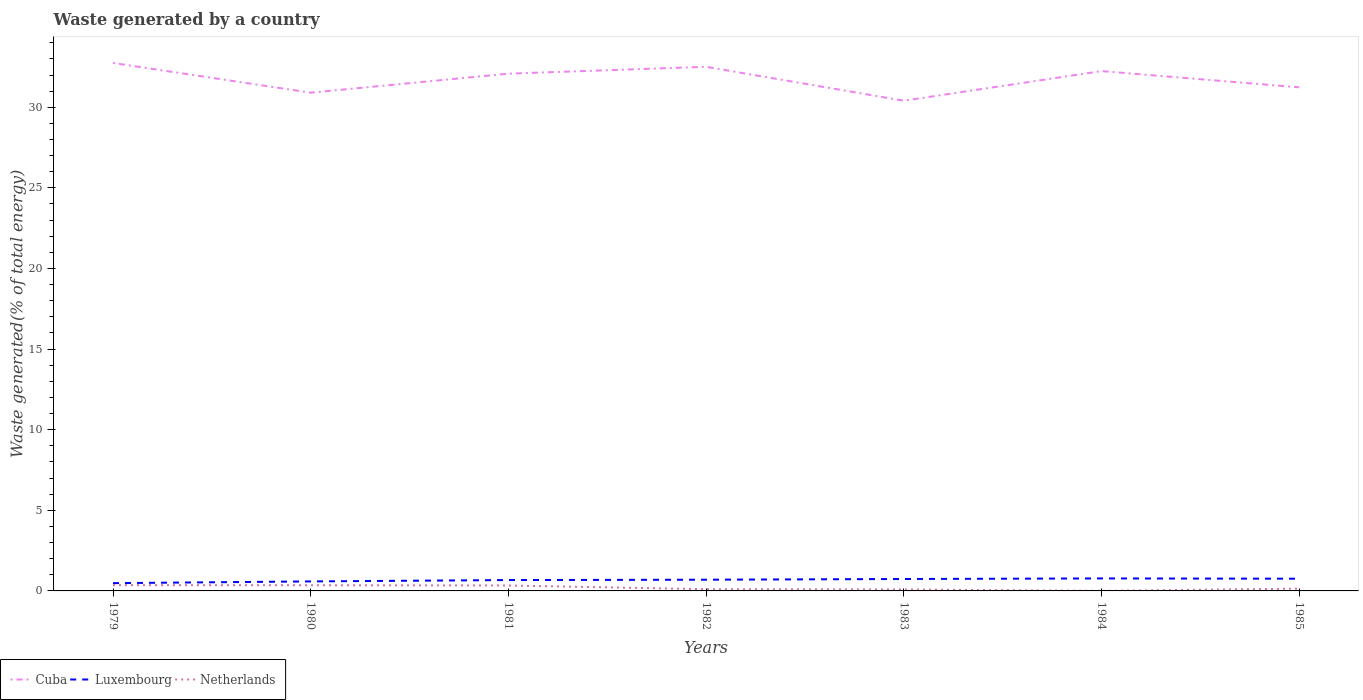How many different coloured lines are there?
Offer a terse response. 3. Is the number of lines equal to the number of legend labels?
Provide a short and direct response. Yes. Across all years, what is the maximum total waste generated in Netherlands?
Offer a terse response. 0.01. What is the total total waste generated in Cuba in the graph?
Provide a short and direct response. -1.61. What is the difference between the highest and the second highest total waste generated in Cuba?
Give a very brief answer. 2.34. Is the total waste generated in Luxembourg strictly greater than the total waste generated in Cuba over the years?
Offer a very short reply. Yes. How many lines are there?
Give a very brief answer. 3. What is the difference between two consecutive major ticks on the Y-axis?
Your answer should be very brief. 5. Where does the legend appear in the graph?
Make the answer very short. Bottom left. How are the legend labels stacked?
Offer a very short reply. Horizontal. What is the title of the graph?
Provide a succinct answer. Waste generated by a country. Does "Middle income" appear as one of the legend labels in the graph?
Give a very brief answer. No. What is the label or title of the Y-axis?
Ensure brevity in your answer.  Waste generated(% of total energy). What is the Waste generated(% of total energy) in Cuba in 1979?
Your response must be concise. 32.75. What is the Waste generated(% of total energy) of Luxembourg in 1979?
Your answer should be very brief. 0.48. What is the Waste generated(% of total energy) of Netherlands in 1979?
Offer a terse response. 0.36. What is the Waste generated(% of total energy) in Cuba in 1980?
Your response must be concise. 30.9. What is the Waste generated(% of total energy) in Luxembourg in 1980?
Offer a terse response. 0.59. What is the Waste generated(% of total energy) in Netherlands in 1980?
Keep it short and to the point. 0.35. What is the Waste generated(% of total energy) in Cuba in 1981?
Keep it short and to the point. 32.08. What is the Waste generated(% of total energy) of Luxembourg in 1981?
Provide a short and direct response. 0.67. What is the Waste generated(% of total energy) in Netherlands in 1981?
Offer a very short reply. 0.33. What is the Waste generated(% of total energy) of Cuba in 1982?
Offer a very short reply. 32.51. What is the Waste generated(% of total energy) in Luxembourg in 1982?
Ensure brevity in your answer.  0.7. What is the Waste generated(% of total energy) in Netherlands in 1982?
Give a very brief answer. 0.11. What is the Waste generated(% of total energy) in Cuba in 1983?
Provide a short and direct response. 30.41. What is the Waste generated(% of total energy) of Luxembourg in 1983?
Make the answer very short. 0.74. What is the Waste generated(% of total energy) of Netherlands in 1983?
Provide a succinct answer. 0.09. What is the Waste generated(% of total energy) of Cuba in 1984?
Make the answer very short. 32.24. What is the Waste generated(% of total energy) in Luxembourg in 1984?
Ensure brevity in your answer.  0.77. What is the Waste generated(% of total energy) in Netherlands in 1984?
Give a very brief answer. 0.01. What is the Waste generated(% of total energy) of Cuba in 1985?
Make the answer very short. 31.24. What is the Waste generated(% of total energy) of Luxembourg in 1985?
Provide a short and direct response. 0.76. What is the Waste generated(% of total energy) in Netherlands in 1985?
Provide a succinct answer. 0.14. Across all years, what is the maximum Waste generated(% of total energy) in Cuba?
Offer a very short reply. 32.75. Across all years, what is the maximum Waste generated(% of total energy) in Luxembourg?
Provide a succinct answer. 0.77. Across all years, what is the maximum Waste generated(% of total energy) of Netherlands?
Offer a terse response. 0.36. Across all years, what is the minimum Waste generated(% of total energy) in Cuba?
Offer a very short reply. 30.41. Across all years, what is the minimum Waste generated(% of total energy) in Luxembourg?
Your answer should be very brief. 0.48. Across all years, what is the minimum Waste generated(% of total energy) in Netherlands?
Your answer should be compact. 0.01. What is the total Waste generated(% of total energy) in Cuba in the graph?
Give a very brief answer. 222.13. What is the total Waste generated(% of total energy) of Luxembourg in the graph?
Make the answer very short. 4.71. What is the total Waste generated(% of total energy) of Netherlands in the graph?
Provide a succinct answer. 1.39. What is the difference between the Waste generated(% of total energy) of Cuba in 1979 and that in 1980?
Your response must be concise. 1.84. What is the difference between the Waste generated(% of total energy) of Luxembourg in 1979 and that in 1980?
Your response must be concise. -0.11. What is the difference between the Waste generated(% of total energy) in Netherlands in 1979 and that in 1980?
Your response must be concise. 0.01. What is the difference between the Waste generated(% of total energy) in Cuba in 1979 and that in 1981?
Provide a succinct answer. 0.66. What is the difference between the Waste generated(% of total energy) of Luxembourg in 1979 and that in 1981?
Keep it short and to the point. -0.19. What is the difference between the Waste generated(% of total energy) of Netherlands in 1979 and that in 1981?
Offer a terse response. 0.02. What is the difference between the Waste generated(% of total energy) of Cuba in 1979 and that in 1982?
Your answer should be compact. 0.24. What is the difference between the Waste generated(% of total energy) of Luxembourg in 1979 and that in 1982?
Offer a terse response. -0.21. What is the difference between the Waste generated(% of total energy) of Netherlands in 1979 and that in 1982?
Give a very brief answer. 0.25. What is the difference between the Waste generated(% of total energy) of Cuba in 1979 and that in 1983?
Your answer should be compact. 2.34. What is the difference between the Waste generated(% of total energy) in Luxembourg in 1979 and that in 1983?
Keep it short and to the point. -0.26. What is the difference between the Waste generated(% of total energy) of Netherlands in 1979 and that in 1983?
Your answer should be very brief. 0.27. What is the difference between the Waste generated(% of total energy) of Cuba in 1979 and that in 1984?
Ensure brevity in your answer.  0.5. What is the difference between the Waste generated(% of total energy) of Luxembourg in 1979 and that in 1984?
Ensure brevity in your answer.  -0.29. What is the difference between the Waste generated(% of total energy) of Netherlands in 1979 and that in 1984?
Offer a very short reply. 0.35. What is the difference between the Waste generated(% of total energy) in Cuba in 1979 and that in 1985?
Provide a short and direct response. 1.51. What is the difference between the Waste generated(% of total energy) of Luxembourg in 1979 and that in 1985?
Provide a short and direct response. -0.28. What is the difference between the Waste generated(% of total energy) of Netherlands in 1979 and that in 1985?
Your answer should be very brief. 0.22. What is the difference between the Waste generated(% of total energy) of Cuba in 1980 and that in 1981?
Make the answer very short. -1.18. What is the difference between the Waste generated(% of total energy) of Luxembourg in 1980 and that in 1981?
Make the answer very short. -0.08. What is the difference between the Waste generated(% of total energy) in Netherlands in 1980 and that in 1981?
Provide a short and direct response. 0.02. What is the difference between the Waste generated(% of total energy) of Cuba in 1980 and that in 1982?
Make the answer very short. -1.61. What is the difference between the Waste generated(% of total energy) in Luxembourg in 1980 and that in 1982?
Make the answer very short. -0.11. What is the difference between the Waste generated(% of total energy) of Netherlands in 1980 and that in 1982?
Your response must be concise. 0.24. What is the difference between the Waste generated(% of total energy) of Cuba in 1980 and that in 1983?
Give a very brief answer. 0.5. What is the difference between the Waste generated(% of total energy) of Netherlands in 1980 and that in 1983?
Make the answer very short. 0.26. What is the difference between the Waste generated(% of total energy) of Cuba in 1980 and that in 1984?
Offer a terse response. -1.34. What is the difference between the Waste generated(% of total energy) of Luxembourg in 1980 and that in 1984?
Your response must be concise. -0.18. What is the difference between the Waste generated(% of total energy) of Netherlands in 1980 and that in 1984?
Your answer should be very brief. 0.35. What is the difference between the Waste generated(% of total energy) in Cuba in 1980 and that in 1985?
Your answer should be very brief. -0.33. What is the difference between the Waste generated(% of total energy) in Luxembourg in 1980 and that in 1985?
Offer a terse response. -0.17. What is the difference between the Waste generated(% of total energy) of Netherlands in 1980 and that in 1985?
Provide a short and direct response. 0.21. What is the difference between the Waste generated(% of total energy) in Cuba in 1981 and that in 1982?
Provide a short and direct response. -0.43. What is the difference between the Waste generated(% of total energy) of Luxembourg in 1981 and that in 1982?
Your response must be concise. -0.02. What is the difference between the Waste generated(% of total energy) of Netherlands in 1981 and that in 1982?
Offer a terse response. 0.23. What is the difference between the Waste generated(% of total energy) of Cuba in 1981 and that in 1983?
Your response must be concise. 1.68. What is the difference between the Waste generated(% of total energy) in Luxembourg in 1981 and that in 1983?
Keep it short and to the point. -0.07. What is the difference between the Waste generated(% of total energy) of Netherlands in 1981 and that in 1983?
Your response must be concise. 0.24. What is the difference between the Waste generated(% of total energy) of Cuba in 1981 and that in 1984?
Your response must be concise. -0.16. What is the difference between the Waste generated(% of total energy) in Luxembourg in 1981 and that in 1984?
Make the answer very short. -0.1. What is the difference between the Waste generated(% of total energy) of Netherlands in 1981 and that in 1984?
Keep it short and to the point. 0.33. What is the difference between the Waste generated(% of total energy) of Cuba in 1981 and that in 1985?
Offer a very short reply. 0.85. What is the difference between the Waste generated(% of total energy) of Luxembourg in 1981 and that in 1985?
Provide a short and direct response. -0.08. What is the difference between the Waste generated(% of total energy) in Netherlands in 1981 and that in 1985?
Provide a succinct answer. 0.19. What is the difference between the Waste generated(% of total energy) in Cuba in 1982 and that in 1983?
Your answer should be very brief. 2.1. What is the difference between the Waste generated(% of total energy) in Luxembourg in 1982 and that in 1983?
Offer a very short reply. -0.04. What is the difference between the Waste generated(% of total energy) of Netherlands in 1982 and that in 1983?
Your response must be concise. 0.02. What is the difference between the Waste generated(% of total energy) in Cuba in 1982 and that in 1984?
Give a very brief answer. 0.27. What is the difference between the Waste generated(% of total energy) in Luxembourg in 1982 and that in 1984?
Your answer should be compact. -0.08. What is the difference between the Waste generated(% of total energy) in Netherlands in 1982 and that in 1984?
Provide a short and direct response. 0.1. What is the difference between the Waste generated(% of total energy) of Cuba in 1982 and that in 1985?
Provide a succinct answer. 1.27. What is the difference between the Waste generated(% of total energy) of Luxembourg in 1982 and that in 1985?
Offer a terse response. -0.06. What is the difference between the Waste generated(% of total energy) in Netherlands in 1982 and that in 1985?
Ensure brevity in your answer.  -0.03. What is the difference between the Waste generated(% of total energy) in Cuba in 1983 and that in 1984?
Offer a very short reply. -1.84. What is the difference between the Waste generated(% of total energy) in Luxembourg in 1983 and that in 1984?
Provide a succinct answer. -0.03. What is the difference between the Waste generated(% of total energy) of Netherlands in 1983 and that in 1984?
Provide a short and direct response. 0.08. What is the difference between the Waste generated(% of total energy) of Cuba in 1983 and that in 1985?
Offer a very short reply. -0.83. What is the difference between the Waste generated(% of total energy) of Luxembourg in 1983 and that in 1985?
Provide a short and direct response. -0.02. What is the difference between the Waste generated(% of total energy) of Netherlands in 1983 and that in 1985?
Offer a terse response. -0.05. What is the difference between the Waste generated(% of total energy) in Luxembourg in 1984 and that in 1985?
Give a very brief answer. 0.02. What is the difference between the Waste generated(% of total energy) in Netherlands in 1984 and that in 1985?
Ensure brevity in your answer.  -0.14. What is the difference between the Waste generated(% of total energy) of Cuba in 1979 and the Waste generated(% of total energy) of Luxembourg in 1980?
Provide a succinct answer. 32.16. What is the difference between the Waste generated(% of total energy) in Cuba in 1979 and the Waste generated(% of total energy) in Netherlands in 1980?
Provide a short and direct response. 32.39. What is the difference between the Waste generated(% of total energy) in Luxembourg in 1979 and the Waste generated(% of total energy) in Netherlands in 1980?
Keep it short and to the point. 0.13. What is the difference between the Waste generated(% of total energy) of Cuba in 1979 and the Waste generated(% of total energy) of Luxembourg in 1981?
Give a very brief answer. 32.07. What is the difference between the Waste generated(% of total energy) of Cuba in 1979 and the Waste generated(% of total energy) of Netherlands in 1981?
Provide a short and direct response. 32.41. What is the difference between the Waste generated(% of total energy) in Luxembourg in 1979 and the Waste generated(% of total energy) in Netherlands in 1981?
Your answer should be very brief. 0.15. What is the difference between the Waste generated(% of total energy) in Cuba in 1979 and the Waste generated(% of total energy) in Luxembourg in 1982?
Provide a short and direct response. 32.05. What is the difference between the Waste generated(% of total energy) of Cuba in 1979 and the Waste generated(% of total energy) of Netherlands in 1982?
Ensure brevity in your answer.  32.64. What is the difference between the Waste generated(% of total energy) of Luxembourg in 1979 and the Waste generated(% of total energy) of Netherlands in 1982?
Give a very brief answer. 0.37. What is the difference between the Waste generated(% of total energy) of Cuba in 1979 and the Waste generated(% of total energy) of Luxembourg in 1983?
Keep it short and to the point. 32.01. What is the difference between the Waste generated(% of total energy) of Cuba in 1979 and the Waste generated(% of total energy) of Netherlands in 1983?
Offer a very short reply. 32.66. What is the difference between the Waste generated(% of total energy) in Luxembourg in 1979 and the Waste generated(% of total energy) in Netherlands in 1983?
Keep it short and to the point. 0.39. What is the difference between the Waste generated(% of total energy) of Cuba in 1979 and the Waste generated(% of total energy) of Luxembourg in 1984?
Ensure brevity in your answer.  31.97. What is the difference between the Waste generated(% of total energy) in Cuba in 1979 and the Waste generated(% of total energy) in Netherlands in 1984?
Give a very brief answer. 32.74. What is the difference between the Waste generated(% of total energy) of Luxembourg in 1979 and the Waste generated(% of total energy) of Netherlands in 1984?
Your response must be concise. 0.48. What is the difference between the Waste generated(% of total energy) of Cuba in 1979 and the Waste generated(% of total energy) of Luxembourg in 1985?
Your answer should be very brief. 31.99. What is the difference between the Waste generated(% of total energy) of Cuba in 1979 and the Waste generated(% of total energy) of Netherlands in 1985?
Give a very brief answer. 32.61. What is the difference between the Waste generated(% of total energy) of Luxembourg in 1979 and the Waste generated(% of total energy) of Netherlands in 1985?
Keep it short and to the point. 0.34. What is the difference between the Waste generated(% of total energy) in Cuba in 1980 and the Waste generated(% of total energy) in Luxembourg in 1981?
Keep it short and to the point. 30.23. What is the difference between the Waste generated(% of total energy) of Cuba in 1980 and the Waste generated(% of total energy) of Netherlands in 1981?
Offer a terse response. 30.57. What is the difference between the Waste generated(% of total energy) of Luxembourg in 1980 and the Waste generated(% of total energy) of Netherlands in 1981?
Provide a short and direct response. 0.25. What is the difference between the Waste generated(% of total energy) in Cuba in 1980 and the Waste generated(% of total energy) in Luxembourg in 1982?
Offer a very short reply. 30.21. What is the difference between the Waste generated(% of total energy) of Cuba in 1980 and the Waste generated(% of total energy) of Netherlands in 1982?
Keep it short and to the point. 30.8. What is the difference between the Waste generated(% of total energy) in Luxembourg in 1980 and the Waste generated(% of total energy) in Netherlands in 1982?
Give a very brief answer. 0.48. What is the difference between the Waste generated(% of total energy) of Cuba in 1980 and the Waste generated(% of total energy) of Luxembourg in 1983?
Offer a terse response. 30.16. What is the difference between the Waste generated(% of total energy) of Cuba in 1980 and the Waste generated(% of total energy) of Netherlands in 1983?
Keep it short and to the point. 30.81. What is the difference between the Waste generated(% of total energy) of Luxembourg in 1980 and the Waste generated(% of total energy) of Netherlands in 1983?
Give a very brief answer. 0.5. What is the difference between the Waste generated(% of total energy) of Cuba in 1980 and the Waste generated(% of total energy) of Luxembourg in 1984?
Provide a succinct answer. 30.13. What is the difference between the Waste generated(% of total energy) of Cuba in 1980 and the Waste generated(% of total energy) of Netherlands in 1984?
Your answer should be very brief. 30.9. What is the difference between the Waste generated(% of total energy) in Luxembourg in 1980 and the Waste generated(% of total energy) in Netherlands in 1984?
Your answer should be very brief. 0.58. What is the difference between the Waste generated(% of total energy) of Cuba in 1980 and the Waste generated(% of total energy) of Luxembourg in 1985?
Provide a short and direct response. 30.15. What is the difference between the Waste generated(% of total energy) of Cuba in 1980 and the Waste generated(% of total energy) of Netherlands in 1985?
Make the answer very short. 30.76. What is the difference between the Waste generated(% of total energy) in Luxembourg in 1980 and the Waste generated(% of total energy) in Netherlands in 1985?
Offer a terse response. 0.45. What is the difference between the Waste generated(% of total energy) of Cuba in 1981 and the Waste generated(% of total energy) of Luxembourg in 1982?
Offer a terse response. 31.39. What is the difference between the Waste generated(% of total energy) in Cuba in 1981 and the Waste generated(% of total energy) in Netherlands in 1982?
Your answer should be compact. 31.98. What is the difference between the Waste generated(% of total energy) of Luxembourg in 1981 and the Waste generated(% of total energy) of Netherlands in 1982?
Your answer should be very brief. 0.57. What is the difference between the Waste generated(% of total energy) in Cuba in 1981 and the Waste generated(% of total energy) in Luxembourg in 1983?
Keep it short and to the point. 31.34. What is the difference between the Waste generated(% of total energy) of Cuba in 1981 and the Waste generated(% of total energy) of Netherlands in 1983?
Provide a succinct answer. 31.99. What is the difference between the Waste generated(% of total energy) in Luxembourg in 1981 and the Waste generated(% of total energy) in Netherlands in 1983?
Give a very brief answer. 0.58. What is the difference between the Waste generated(% of total energy) of Cuba in 1981 and the Waste generated(% of total energy) of Luxembourg in 1984?
Provide a succinct answer. 31.31. What is the difference between the Waste generated(% of total energy) of Cuba in 1981 and the Waste generated(% of total energy) of Netherlands in 1984?
Your answer should be compact. 32.08. What is the difference between the Waste generated(% of total energy) of Luxembourg in 1981 and the Waste generated(% of total energy) of Netherlands in 1984?
Provide a succinct answer. 0.67. What is the difference between the Waste generated(% of total energy) of Cuba in 1981 and the Waste generated(% of total energy) of Luxembourg in 1985?
Your answer should be compact. 31.33. What is the difference between the Waste generated(% of total energy) in Cuba in 1981 and the Waste generated(% of total energy) in Netherlands in 1985?
Provide a succinct answer. 31.94. What is the difference between the Waste generated(% of total energy) in Luxembourg in 1981 and the Waste generated(% of total energy) in Netherlands in 1985?
Provide a short and direct response. 0.53. What is the difference between the Waste generated(% of total energy) of Cuba in 1982 and the Waste generated(% of total energy) of Luxembourg in 1983?
Offer a very short reply. 31.77. What is the difference between the Waste generated(% of total energy) of Cuba in 1982 and the Waste generated(% of total energy) of Netherlands in 1983?
Offer a terse response. 32.42. What is the difference between the Waste generated(% of total energy) of Luxembourg in 1982 and the Waste generated(% of total energy) of Netherlands in 1983?
Your response must be concise. 0.61. What is the difference between the Waste generated(% of total energy) in Cuba in 1982 and the Waste generated(% of total energy) in Luxembourg in 1984?
Your answer should be compact. 31.74. What is the difference between the Waste generated(% of total energy) of Cuba in 1982 and the Waste generated(% of total energy) of Netherlands in 1984?
Ensure brevity in your answer.  32.5. What is the difference between the Waste generated(% of total energy) in Luxembourg in 1982 and the Waste generated(% of total energy) in Netherlands in 1984?
Ensure brevity in your answer.  0.69. What is the difference between the Waste generated(% of total energy) of Cuba in 1982 and the Waste generated(% of total energy) of Luxembourg in 1985?
Make the answer very short. 31.75. What is the difference between the Waste generated(% of total energy) in Cuba in 1982 and the Waste generated(% of total energy) in Netherlands in 1985?
Make the answer very short. 32.37. What is the difference between the Waste generated(% of total energy) of Luxembourg in 1982 and the Waste generated(% of total energy) of Netherlands in 1985?
Provide a succinct answer. 0.55. What is the difference between the Waste generated(% of total energy) of Cuba in 1983 and the Waste generated(% of total energy) of Luxembourg in 1984?
Ensure brevity in your answer.  29.63. What is the difference between the Waste generated(% of total energy) of Cuba in 1983 and the Waste generated(% of total energy) of Netherlands in 1984?
Offer a terse response. 30.4. What is the difference between the Waste generated(% of total energy) in Luxembourg in 1983 and the Waste generated(% of total energy) in Netherlands in 1984?
Provide a succinct answer. 0.73. What is the difference between the Waste generated(% of total energy) of Cuba in 1983 and the Waste generated(% of total energy) of Luxembourg in 1985?
Make the answer very short. 29.65. What is the difference between the Waste generated(% of total energy) of Cuba in 1983 and the Waste generated(% of total energy) of Netherlands in 1985?
Make the answer very short. 30.27. What is the difference between the Waste generated(% of total energy) in Luxembourg in 1983 and the Waste generated(% of total energy) in Netherlands in 1985?
Make the answer very short. 0.6. What is the difference between the Waste generated(% of total energy) in Cuba in 1984 and the Waste generated(% of total energy) in Luxembourg in 1985?
Make the answer very short. 31.49. What is the difference between the Waste generated(% of total energy) of Cuba in 1984 and the Waste generated(% of total energy) of Netherlands in 1985?
Your answer should be compact. 32.1. What is the difference between the Waste generated(% of total energy) of Luxembourg in 1984 and the Waste generated(% of total energy) of Netherlands in 1985?
Provide a succinct answer. 0.63. What is the average Waste generated(% of total energy) in Cuba per year?
Offer a very short reply. 31.73. What is the average Waste generated(% of total energy) of Luxembourg per year?
Provide a short and direct response. 0.67. What is the average Waste generated(% of total energy) of Netherlands per year?
Your answer should be very brief. 0.2. In the year 1979, what is the difference between the Waste generated(% of total energy) in Cuba and Waste generated(% of total energy) in Luxembourg?
Offer a terse response. 32.27. In the year 1979, what is the difference between the Waste generated(% of total energy) in Cuba and Waste generated(% of total energy) in Netherlands?
Provide a succinct answer. 32.39. In the year 1979, what is the difference between the Waste generated(% of total energy) in Luxembourg and Waste generated(% of total energy) in Netherlands?
Provide a short and direct response. 0.12. In the year 1980, what is the difference between the Waste generated(% of total energy) of Cuba and Waste generated(% of total energy) of Luxembourg?
Your answer should be compact. 30.31. In the year 1980, what is the difference between the Waste generated(% of total energy) of Cuba and Waste generated(% of total energy) of Netherlands?
Your answer should be very brief. 30.55. In the year 1980, what is the difference between the Waste generated(% of total energy) of Luxembourg and Waste generated(% of total energy) of Netherlands?
Your response must be concise. 0.24. In the year 1981, what is the difference between the Waste generated(% of total energy) in Cuba and Waste generated(% of total energy) in Luxembourg?
Your answer should be compact. 31.41. In the year 1981, what is the difference between the Waste generated(% of total energy) in Cuba and Waste generated(% of total energy) in Netherlands?
Ensure brevity in your answer.  31.75. In the year 1981, what is the difference between the Waste generated(% of total energy) in Luxembourg and Waste generated(% of total energy) in Netherlands?
Give a very brief answer. 0.34. In the year 1982, what is the difference between the Waste generated(% of total energy) in Cuba and Waste generated(% of total energy) in Luxembourg?
Your answer should be compact. 31.81. In the year 1982, what is the difference between the Waste generated(% of total energy) of Cuba and Waste generated(% of total energy) of Netherlands?
Offer a very short reply. 32.4. In the year 1982, what is the difference between the Waste generated(% of total energy) in Luxembourg and Waste generated(% of total energy) in Netherlands?
Offer a terse response. 0.59. In the year 1983, what is the difference between the Waste generated(% of total energy) in Cuba and Waste generated(% of total energy) in Luxembourg?
Provide a short and direct response. 29.67. In the year 1983, what is the difference between the Waste generated(% of total energy) in Cuba and Waste generated(% of total energy) in Netherlands?
Give a very brief answer. 30.32. In the year 1983, what is the difference between the Waste generated(% of total energy) of Luxembourg and Waste generated(% of total energy) of Netherlands?
Offer a terse response. 0.65. In the year 1984, what is the difference between the Waste generated(% of total energy) of Cuba and Waste generated(% of total energy) of Luxembourg?
Make the answer very short. 31.47. In the year 1984, what is the difference between the Waste generated(% of total energy) of Cuba and Waste generated(% of total energy) of Netherlands?
Make the answer very short. 32.24. In the year 1984, what is the difference between the Waste generated(% of total energy) of Luxembourg and Waste generated(% of total energy) of Netherlands?
Ensure brevity in your answer.  0.77. In the year 1985, what is the difference between the Waste generated(% of total energy) in Cuba and Waste generated(% of total energy) in Luxembourg?
Ensure brevity in your answer.  30.48. In the year 1985, what is the difference between the Waste generated(% of total energy) in Cuba and Waste generated(% of total energy) in Netherlands?
Offer a terse response. 31.1. In the year 1985, what is the difference between the Waste generated(% of total energy) of Luxembourg and Waste generated(% of total energy) of Netherlands?
Your response must be concise. 0.62. What is the ratio of the Waste generated(% of total energy) of Cuba in 1979 to that in 1980?
Keep it short and to the point. 1.06. What is the ratio of the Waste generated(% of total energy) of Luxembourg in 1979 to that in 1980?
Make the answer very short. 0.82. What is the ratio of the Waste generated(% of total energy) of Cuba in 1979 to that in 1981?
Your answer should be compact. 1.02. What is the ratio of the Waste generated(% of total energy) in Luxembourg in 1979 to that in 1981?
Ensure brevity in your answer.  0.72. What is the ratio of the Waste generated(% of total energy) in Netherlands in 1979 to that in 1981?
Ensure brevity in your answer.  1.07. What is the ratio of the Waste generated(% of total energy) of Cuba in 1979 to that in 1982?
Keep it short and to the point. 1.01. What is the ratio of the Waste generated(% of total energy) in Luxembourg in 1979 to that in 1982?
Ensure brevity in your answer.  0.69. What is the ratio of the Waste generated(% of total energy) in Netherlands in 1979 to that in 1982?
Ensure brevity in your answer.  3.33. What is the ratio of the Waste generated(% of total energy) in Cuba in 1979 to that in 1983?
Your answer should be very brief. 1.08. What is the ratio of the Waste generated(% of total energy) of Luxembourg in 1979 to that in 1983?
Your answer should be compact. 0.65. What is the ratio of the Waste generated(% of total energy) of Netherlands in 1979 to that in 1983?
Offer a very short reply. 3.98. What is the ratio of the Waste generated(% of total energy) in Cuba in 1979 to that in 1984?
Your answer should be compact. 1.02. What is the ratio of the Waste generated(% of total energy) of Luxembourg in 1979 to that in 1984?
Your answer should be compact. 0.62. What is the ratio of the Waste generated(% of total energy) in Netherlands in 1979 to that in 1984?
Offer a very short reply. 57.91. What is the ratio of the Waste generated(% of total energy) of Cuba in 1979 to that in 1985?
Provide a short and direct response. 1.05. What is the ratio of the Waste generated(% of total energy) in Luxembourg in 1979 to that in 1985?
Provide a succinct answer. 0.64. What is the ratio of the Waste generated(% of total energy) in Netherlands in 1979 to that in 1985?
Keep it short and to the point. 2.54. What is the ratio of the Waste generated(% of total energy) in Cuba in 1980 to that in 1981?
Make the answer very short. 0.96. What is the ratio of the Waste generated(% of total energy) in Luxembourg in 1980 to that in 1981?
Your response must be concise. 0.87. What is the ratio of the Waste generated(% of total energy) of Netherlands in 1980 to that in 1981?
Offer a terse response. 1.05. What is the ratio of the Waste generated(% of total energy) of Cuba in 1980 to that in 1982?
Keep it short and to the point. 0.95. What is the ratio of the Waste generated(% of total energy) in Luxembourg in 1980 to that in 1982?
Make the answer very short. 0.85. What is the ratio of the Waste generated(% of total energy) in Netherlands in 1980 to that in 1982?
Keep it short and to the point. 3.28. What is the ratio of the Waste generated(% of total energy) in Cuba in 1980 to that in 1983?
Make the answer very short. 1.02. What is the ratio of the Waste generated(% of total energy) of Luxembourg in 1980 to that in 1983?
Give a very brief answer. 0.8. What is the ratio of the Waste generated(% of total energy) in Netherlands in 1980 to that in 1983?
Provide a succinct answer. 3.92. What is the ratio of the Waste generated(% of total energy) of Cuba in 1980 to that in 1984?
Offer a very short reply. 0.96. What is the ratio of the Waste generated(% of total energy) of Luxembourg in 1980 to that in 1984?
Provide a succinct answer. 0.76. What is the ratio of the Waste generated(% of total energy) of Netherlands in 1980 to that in 1984?
Make the answer very short. 57. What is the ratio of the Waste generated(% of total energy) of Cuba in 1980 to that in 1985?
Offer a terse response. 0.99. What is the ratio of the Waste generated(% of total energy) of Luxembourg in 1980 to that in 1985?
Ensure brevity in your answer.  0.78. What is the ratio of the Waste generated(% of total energy) in Netherlands in 1980 to that in 1985?
Make the answer very short. 2.5. What is the ratio of the Waste generated(% of total energy) of Cuba in 1981 to that in 1982?
Provide a short and direct response. 0.99. What is the ratio of the Waste generated(% of total energy) of Luxembourg in 1981 to that in 1982?
Offer a terse response. 0.97. What is the ratio of the Waste generated(% of total energy) of Netherlands in 1981 to that in 1982?
Ensure brevity in your answer.  3.11. What is the ratio of the Waste generated(% of total energy) in Cuba in 1981 to that in 1983?
Your answer should be compact. 1.06. What is the ratio of the Waste generated(% of total energy) of Luxembourg in 1981 to that in 1983?
Offer a very short reply. 0.91. What is the ratio of the Waste generated(% of total energy) in Netherlands in 1981 to that in 1983?
Provide a short and direct response. 3.72. What is the ratio of the Waste generated(% of total energy) in Cuba in 1981 to that in 1984?
Provide a succinct answer. 1. What is the ratio of the Waste generated(% of total energy) of Luxembourg in 1981 to that in 1984?
Your response must be concise. 0.87. What is the ratio of the Waste generated(% of total energy) in Netherlands in 1981 to that in 1984?
Offer a very short reply. 54.13. What is the ratio of the Waste generated(% of total energy) in Cuba in 1981 to that in 1985?
Your answer should be very brief. 1.03. What is the ratio of the Waste generated(% of total energy) of Luxembourg in 1981 to that in 1985?
Keep it short and to the point. 0.89. What is the ratio of the Waste generated(% of total energy) of Netherlands in 1981 to that in 1985?
Your response must be concise. 2.37. What is the ratio of the Waste generated(% of total energy) in Cuba in 1982 to that in 1983?
Ensure brevity in your answer.  1.07. What is the ratio of the Waste generated(% of total energy) in Luxembourg in 1982 to that in 1983?
Ensure brevity in your answer.  0.94. What is the ratio of the Waste generated(% of total energy) of Netherlands in 1982 to that in 1983?
Keep it short and to the point. 1.2. What is the ratio of the Waste generated(% of total energy) of Cuba in 1982 to that in 1984?
Your answer should be compact. 1.01. What is the ratio of the Waste generated(% of total energy) in Luxembourg in 1982 to that in 1984?
Make the answer very short. 0.9. What is the ratio of the Waste generated(% of total energy) of Netherlands in 1982 to that in 1984?
Offer a terse response. 17.39. What is the ratio of the Waste generated(% of total energy) in Cuba in 1982 to that in 1985?
Make the answer very short. 1.04. What is the ratio of the Waste generated(% of total energy) of Luxembourg in 1982 to that in 1985?
Give a very brief answer. 0.92. What is the ratio of the Waste generated(% of total energy) of Netherlands in 1982 to that in 1985?
Give a very brief answer. 0.76. What is the ratio of the Waste generated(% of total energy) in Cuba in 1983 to that in 1984?
Offer a very short reply. 0.94. What is the ratio of the Waste generated(% of total energy) of Luxembourg in 1983 to that in 1984?
Offer a terse response. 0.96. What is the ratio of the Waste generated(% of total energy) of Netherlands in 1983 to that in 1984?
Ensure brevity in your answer.  14.55. What is the ratio of the Waste generated(% of total energy) of Cuba in 1983 to that in 1985?
Offer a terse response. 0.97. What is the ratio of the Waste generated(% of total energy) of Luxembourg in 1983 to that in 1985?
Your response must be concise. 0.98. What is the ratio of the Waste generated(% of total energy) of Netherlands in 1983 to that in 1985?
Your answer should be very brief. 0.64. What is the ratio of the Waste generated(% of total energy) of Cuba in 1984 to that in 1985?
Offer a terse response. 1.03. What is the ratio of the Waste generated(% of total energy) in Luxembourg in 1984 to that in 1985?
Give a very brief answer. 1.02. What is the ratio of the Waste generated(% of total energy) of Netherlands in 1984 to that in 1985?
Offer a terse response. 0.04. What is the difference between the highest and the second highest Waste generated(% of total energy) of Cuba?
Make the answer very short. 0.24. What is the difference between the highest and the second highest Waste generated(% of total energy) of Luxembourg?
Ensure brevity in your answer.  0.02. What is the difference between the highest and the second highest Waste generated(% of total energy) in Netherlands?
Your answer should be compact. 0.01. What is the difference between the highest and the lowest Waste generated(% of total energy) of Cuba?
Your answer should be compact. 2.34. What is the difference between the highest and the lowest Waste generated(% of total energy) of Luxembourg?
Your answer should be compact. 0.29. What is the difference between the highest and the lowest Waste generated(% of total energy) of Netherlands?
Give a very brief answer. 0.35. 